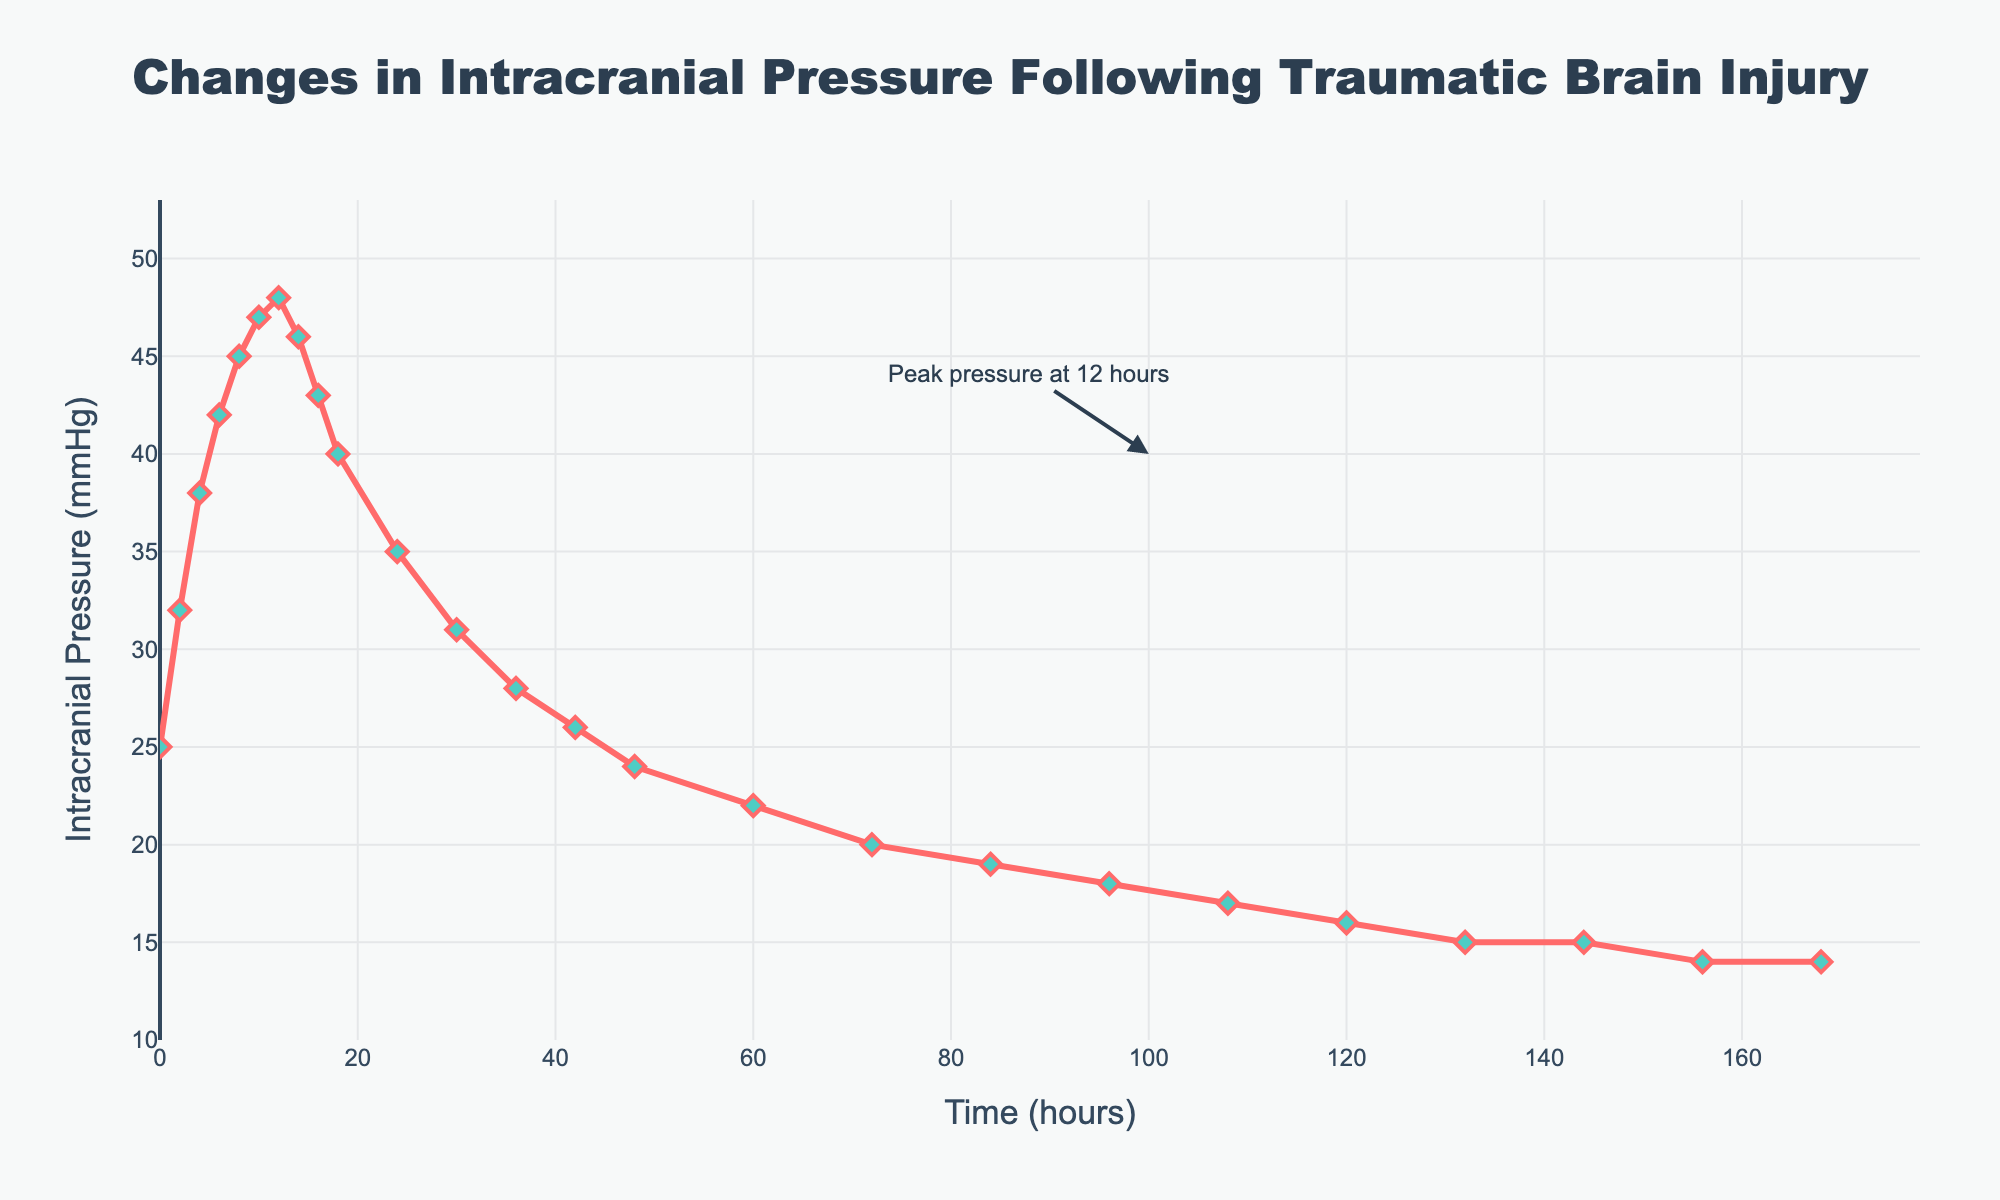What is the peak intracranial pressure and at what time does it occur? The peak intracranial pressure can be identified by looking at the highest point on the line chart. The annotation also points out that the peak pressure occurs at 12 hours.
Answer: 48 mmHg at 12 hours By how much does the intracranial pressure decrease from its peak to 24 hours later? The peak pressure is 48 mmHg at 12 hours. The pressure at 24 hours is 35 mmHg. The decrease is the difference between these two values, which is 48 - 35.
Answer: 13 mmHg What is the average intracranial pressure over the first 24 hours? The intracranial pressure values at 0, 2, 4, 6, 8, 10, 12, 14, 16, 18, and 24 hours are (25, 32, 38, 42, 45, 47, 48, 46, 43, 40, 35). The sum of these values is 441. There are 11 data points, so the average is 441/11.
Answer: 40.09 mmHg Was there any point after the peak where the intracranial pressure was higher than 45 mmHg? After the peak at 12 hours (48 mmHg), the point at 14 hours is 46 mmHg. Since 46 mmHg is higher than 45 mmHg, the answer is yes.
Answer: Yes, at 14 hours How does the intracranial pressure at 48 hours compare to the pressure at 96 hours? At 48 hours, the pressure is 24 mmHg. At 96 hours, the pressure is 18 mmHg. Comparing these values, 24 mmHg is greater than 18 mmHg.
Answer: 24 mmHg is greater than 18 mmHg What is the median intracranial pressure value over the given time period? The median is the middle value in an ordered list. The values in order are (14, 14, 15, 15, 16, 17, 18, 19, 20, 22, 24, 25, 26, 28, 31, 32, 35, 38, 40, 42, 43, 45, 46, 47, 48). The middle value (13th value) is 26.
Answer: 26 mmHg By what percentage does the intracranial pressure decrease from 6 hours to 60 hours? At 6 hours, the pressure is 42 mmHg. At 60 hours, the pressure is 22 mmHg. The decrease is 42 - 22 = 20 mmHg. The percentage decrease is (20/42) * 100.
Answer: 47.62% What visual features indicate the trend in intracranial pressure over time? The line chart shows a peak and then a gradual decline. The line is continuous and uses markers to indicate data points. The declining trend is shown by the downward slope after the peak.
Answer: Peak, gradual decline, markers What is the range of intracranial pressure values observed in the chart? The range is the difference between the highest and lowest values. The highest value is 48 mmHg, and the lowest is 14 mmHg. The range is 48 - 14.
Answer: 34 mmHg Where does the steepest decline in intracranial pressure occur? By visually inspecting the line chart, the steepest decline appears to occur between 12 and 24 hours, where the pressure drops from 48 mmHg to 35 mmHg.
Answer: Between 12 and 24 hours 